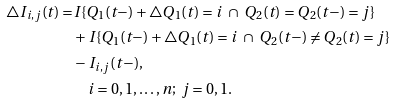Convert formula to latex. <formula><loc_0><loc_0><loc_500><loc_500>\triangle I _ { i , j } ( t ) = & I \{ Q _ { 1 } ( t - ) + \triangle Q _ { 1 } ( t ) = i \ \cap \ Q _ { 2 } ( t ) = Q _ { 2 } ( t - ) = j \} \\ & + I \{ Q _ { 1 } ( t - ) + \triangle Q _ { 1 } ( t ) = i \ \cap \ Q _ { 2 } ( t - ) \neq Q _ { 2 } ( t ) = j \} \\ & - I _ { i , j } ( t - ) , \\ & \quad i = 0 , 1 , \dots , { n } ; \ j = 0 , 1 .</formula> 